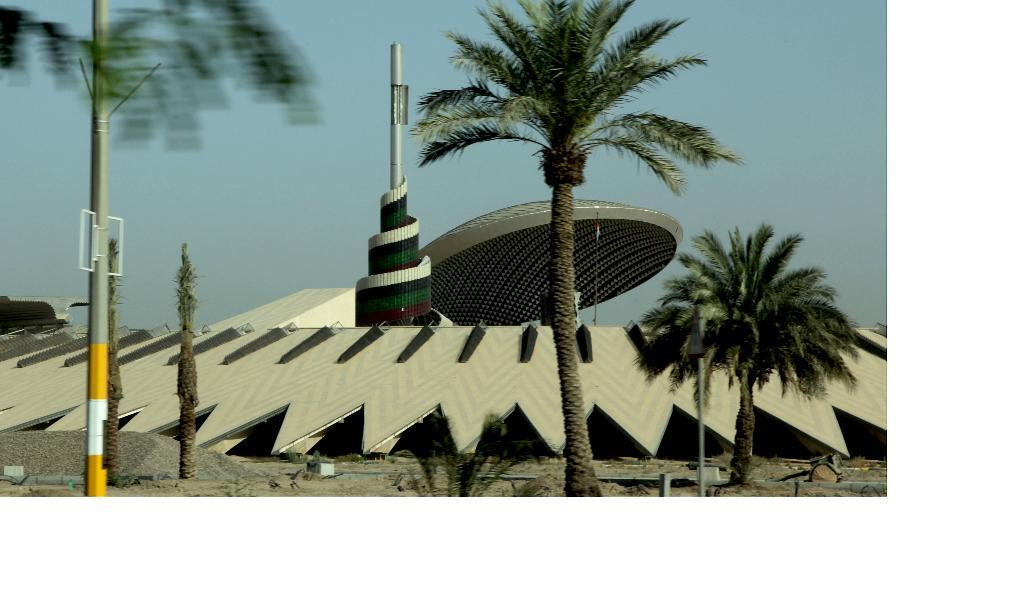What structures can be seen in the image? There are poles in the image. What type of natural elements are present in the image? There are trees and plants in the image. What can be found on the ground in the image? There are stones on the ground in the image. What is visible in the background of the image? In the background, there are objects visible, including a spiral object attached to a pole, a designed metal object, and the sky. Can you see a cat playing with a pencil in the image? There is no cat or pencil present in the image. 